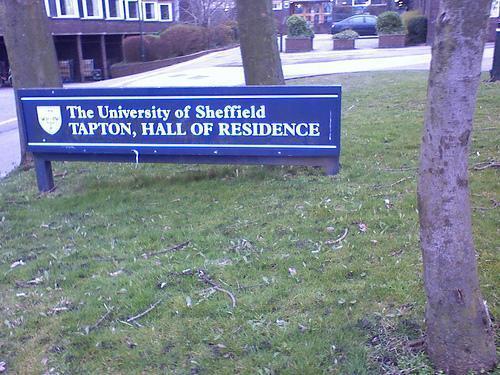How many trees are there?
Give a very brief answer. 3. How many windows are visible on the building?
Give a very brief answer. 6. How many men are in the picture?
Give a very brief answer. 0. 